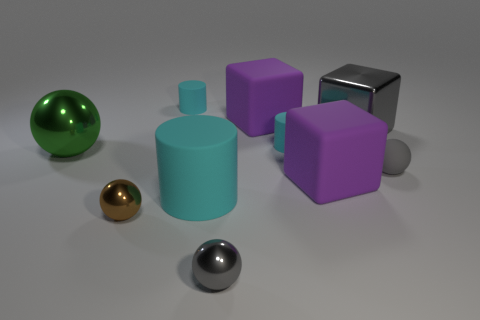There is a gray thing that is the same material as the large cylinder; what size is it?
Make the answer very short. Small. The ball that is left of the big cylinder and in front of the big matte cylinder is what color?
Keep it short and to the point. Brown. Is the shape of the purple object in front of the gray matte ball the same as the metal thing in front of the tiny brown sphere?
Provide a short and direct response. No. What is the material of the purple thing that is in front of the gray matte thing?
Make the answer very short. Rubber. The other ball that is the same color as the tiny rubber ball is what size?
Your answer should be very brief. Small. What number of objects are cyan rubber objects in front of the rubber ball or matte spheres?
Give a very brief answer. 2. Are there an equal number of metal objects that are behind the large metal sphere and small green metallic cylinders?
Your answer should be compact. No. Do the metallic block and the brown shiny object have the same size?
Provide a short and direct response. No. There is a metallic thing that is the same size as the metallic block; what is its color?
Your answer should be very brief. Green. There is a gray block; does it have the same size as the cyan matte thing that is to the right of the large cylinder?
Your answer should be very brief. No. 